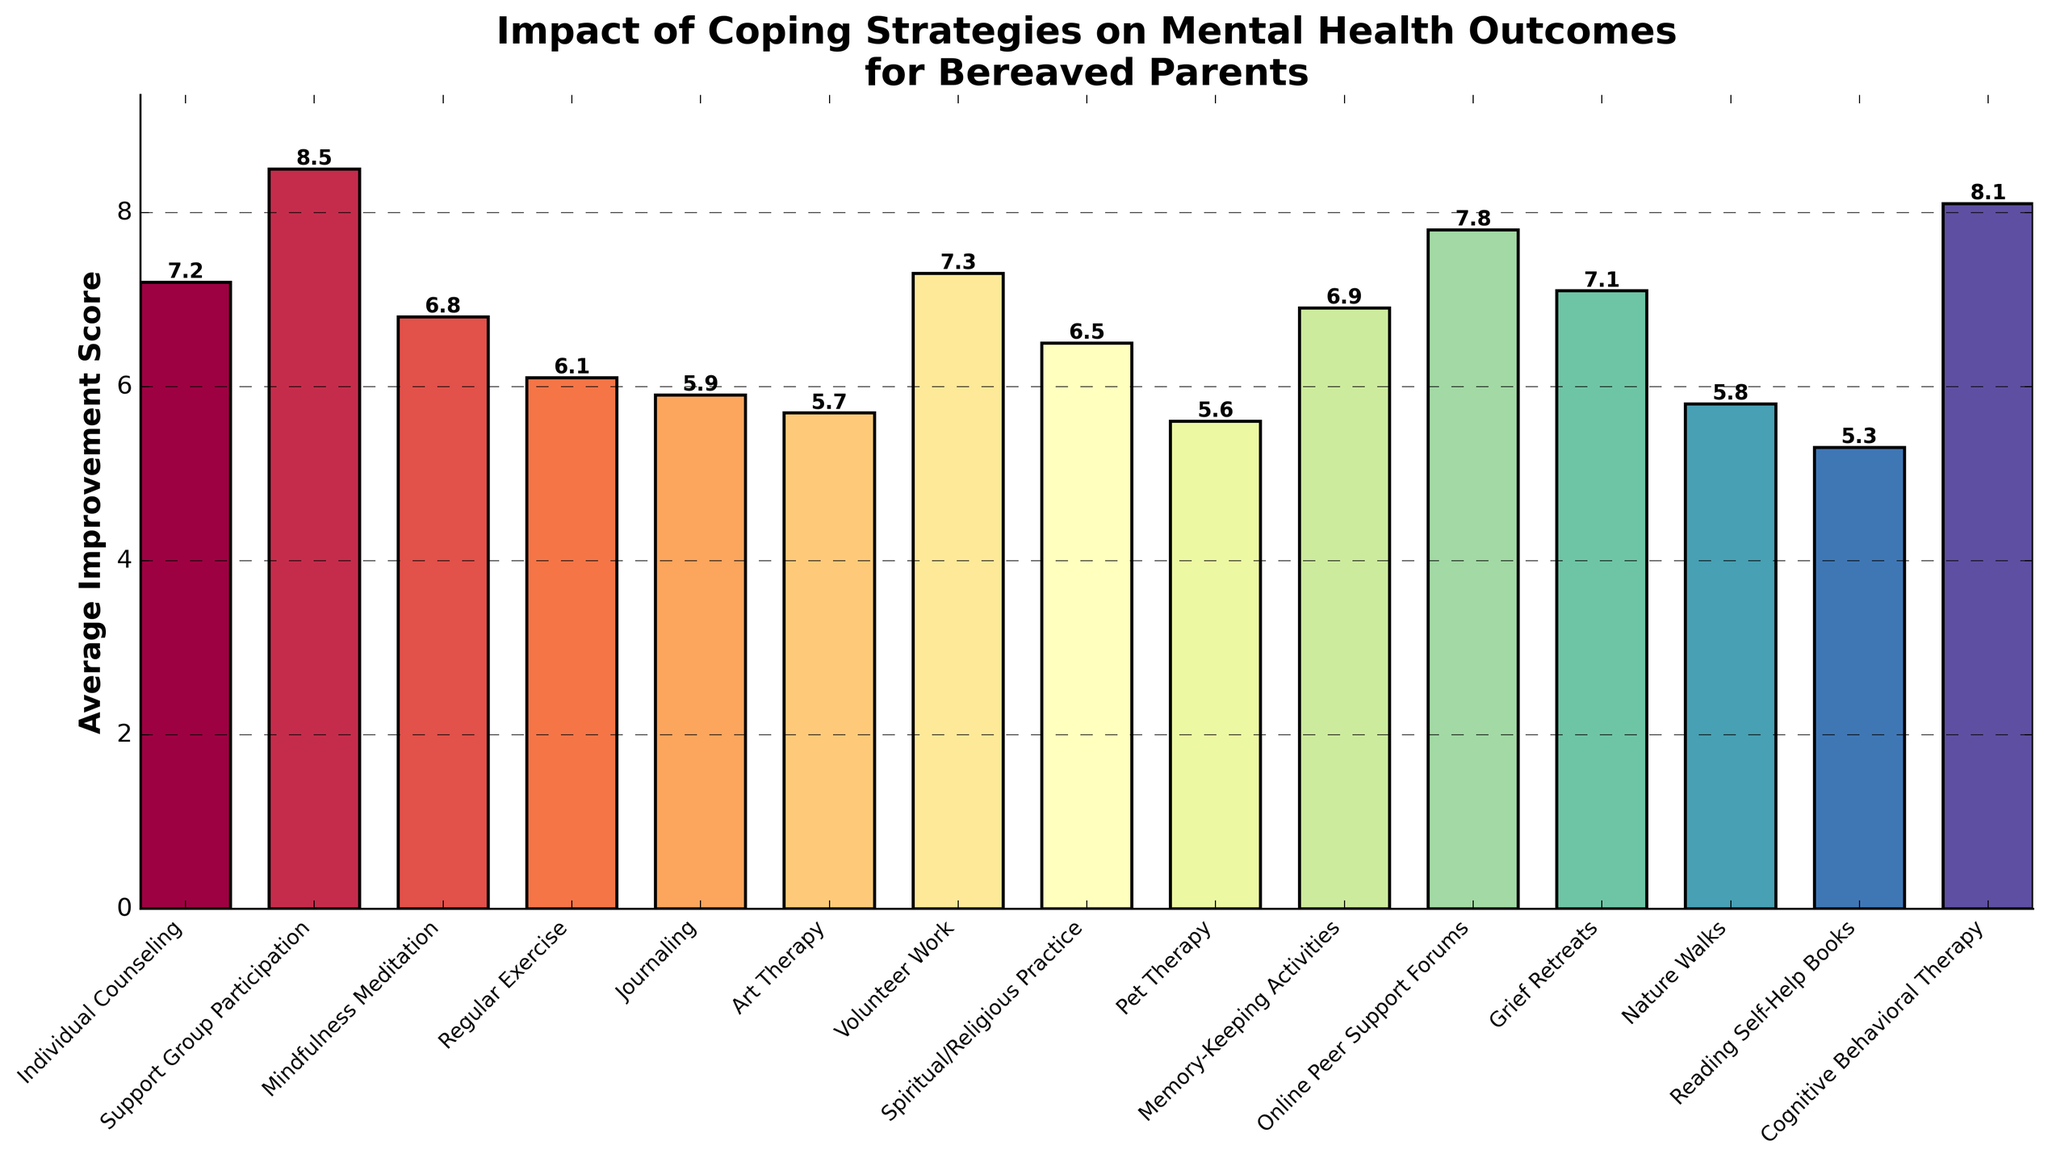Which coping strategy has the highest average improvement score? Identify the bar with the greatest height, which represents the highest average improvement score. In this case, it is the bar for "Support Group Participation" with a score of 8.5
Answer: Support Group Participation What is the average improvement score difference between "Regular Exercise" and "Mindfulness Meditation"? Subtract the average improvement score of "Regular Exercise" (6.1) from "Mindfulness Meditation" (6.8). The difference is 6.8 - 6.1
Answer: 0.7 Which coping strategies have an average improvement score greater than 7.0? Identify bars with heights representing scores higher than 7.0. These include Individual Counseling (7.2), Support Group Participation (8.5), Volunteer Work (7.3), Online Peer Support Forums (7.8), Grief Retreats (7.1), and Cognitive Behavioral Therapy (8.1)
Answer: Individual Counseling, Support Group Participation, Volunteer Work, Online Peer Support Forums, Grief Retreats, Cognitive Behavioral Therapy List the three coping strategies with the lowest average improvement scores. Identify the three bars with the shortest heights. These are Reading Self-Help Books (5.3), Pet Therapy (5.6), and Art Therapy (5.7)
Answer: Reading Self-Help Books, Pet Therapy, Art Therapy What is the sum of the average improvement scores for "Journaling" and "Nature Walks"? Add the scores for "Journaling" (5.9) and "Nature Walks" (5.8). The sum is 5.9 + 5.8
Answer: 11.7 How much higher is the average improvement score for "Cognitive Behavioral Therapy" compared to "Reading Self-Help Books"? Subtract the score for "Reading Self-Help Books" (5.3) from "Cognitive Behavioral Therapy" (8.1). The difference is 8.1 - 5.3
Answer: 2.8 What is the combined average improvement score for “Spiritual/Religious Practice”, “Art Therapy”, and “Nature Walks”? Add the scores for “Spiritual/Religious Practice” (6.5), “Art Therapy” (5.7), and “Nature Walks” (5.8). The sum is 6.5 + 5.7 + 5.8
Answer: 18.0 Which coping strategy has a higher average improvement score: "Memory-Keeping Activities" or "Mindfulness Meditation"? Compare the heights of the bars representing "Memory-Keeping Activities" (6.9) and "Mindfulness Meditation" (6.8). "Memory-Keeping Activities" is slightly higher.
Answer: Memory-Keeping Activities Identify the coping strategy with an average improvement score of 7.1 and explain its relative position compared to "Grief Retreats" and "Individual Counseling". "Grief Retreats" has an average improvement score of 7.1. It is higher than "Individual Counseling" (7.2) and just slightly lower compared to the strategies with scores around 7.0.
Answer: Grief Retreats 